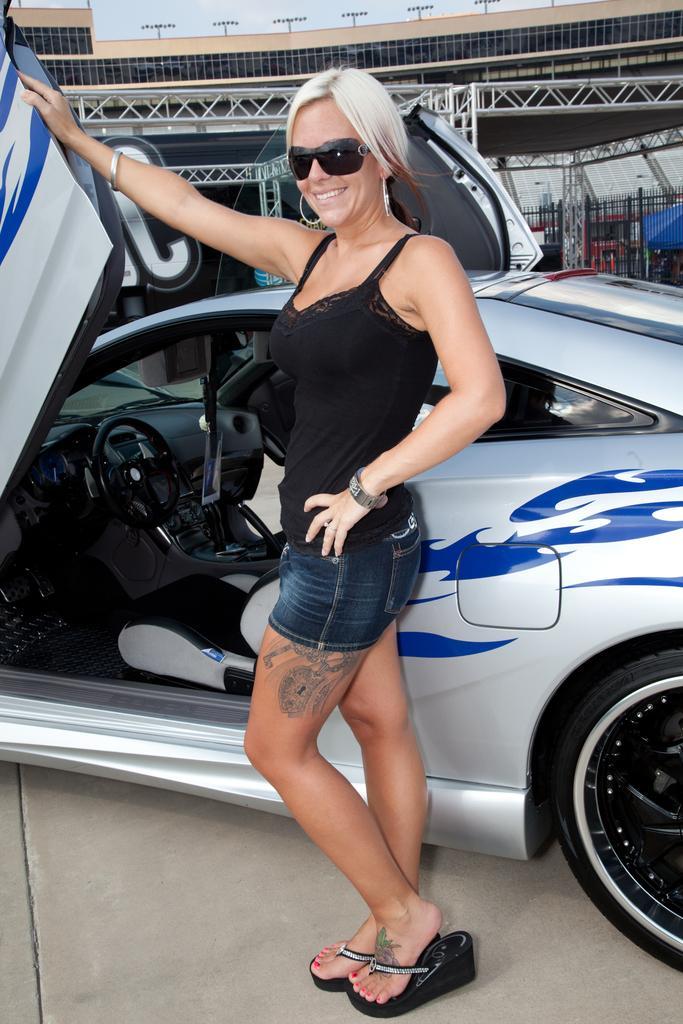In one or two sentences, can you explain what this image depicts? In the foreground of this picture, there is a woman standing near a car. In the background, there is a stadium, light and the sky. 